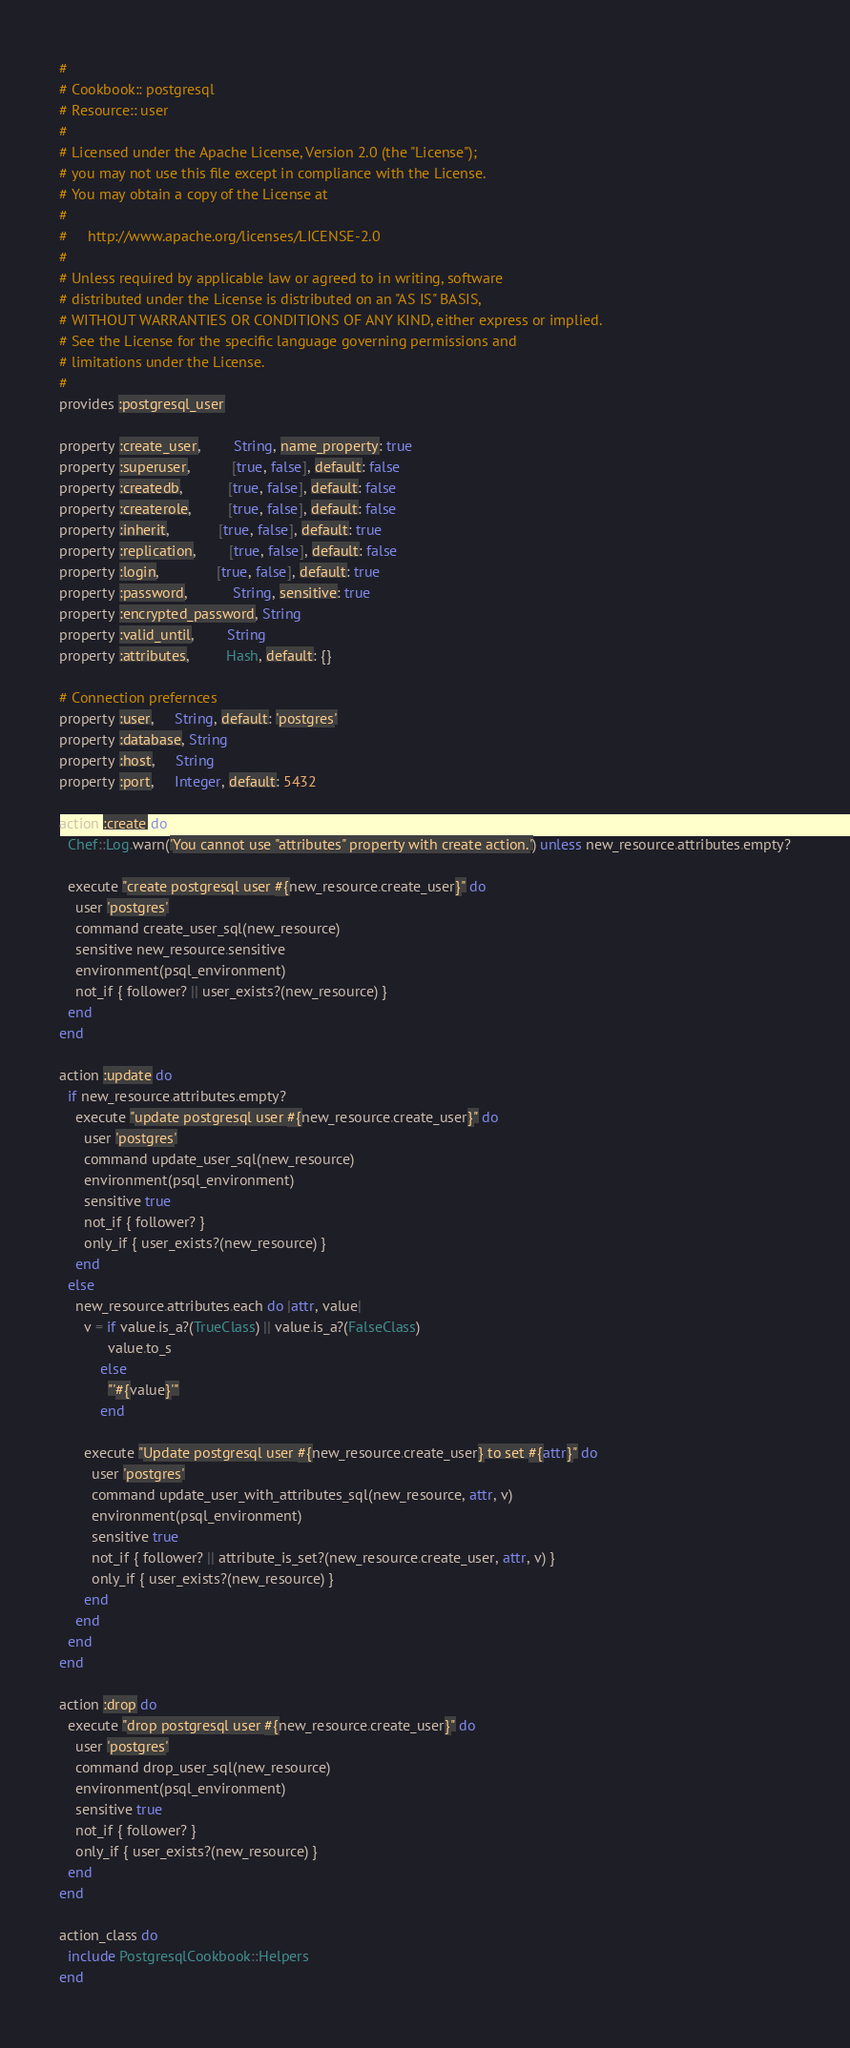Convert code to text. <code><loc_0><loc_0><loc_500><loc_500><_Ruby_>#
# Cookbook:: postgresql
# Resource:: user
#
# Licensed under the Apache License, Version 2.0 (the "License");
# you may not use this file except in compliance with the License.
# You may obtain a copy of the License at
#
#     http://www.apache.org/licenses/LICENSE-2.0
#
# Unless required by applicable law or agreed to in writing, software
# distributed under the License is distributed on an "AS IS" BASIS,
# WITHOUT WARRANTIES OR CONDITIONS OF ANY KIND, either express or implied.
# See the License for the specific language governing permissions and
# limitations under the License.
#
provides :postgresql_user

property :create_user,        String, name_property: true
property :superuser,          [true, false], default: false
property :createdb,           [true, false], default: false
property :createrole,         [true, false], default: false
property :inherit,            [true, false], default: true
property :replication,        [true, false], default: false
property :login,              [true, false], default: true
property :password,           String, sensitive: true
property :encrypted_password, String
property :valid_until,        String
property :attributes,         Hash, default: {}

# Connection prefernces
property :user,     String, default: 'postgres'
property :database, String
property :host,     String
property :port,     Integer, default: 5432

action :create do
  Chef::Log.warn('You cannot use "attributes" property with create action.') unless new_resource.attributes.empty?

  execute "create postgresql user #{new_resource.create_user}" do
    user 'postgres'
    command create_user_sql(new_resource)
    sensitive new_resource.sensitive
    environment(psql_environment)
    not_if { follower? || user_exists?(new_resource) }
  end
end

action :update do
  if new_resource.attributes.empty?
    execute "update postgresql user #{new_resource.create_user}" do
      user 'postgres'
      command update_user_sql(new_resource)
      environment(psql_environment)
      sensitive true
      not_if { follower? }
      only_if { user_exists?(new_resource) }
    end
  else
    new_resource.attributes.each do |attr, value|
      v = if value.is_a?(TrueClass) || value.is_a?(FalseClass)
            value.to_s
          else
            "'#{value}'"
          end

      execute "Update postgresql user #{new_resource.create_user} to set #{attr}" do
        user 'postgres'
        command update_user_with_attributes_sql(new_resource, attr, v)
        environment(psql_environment)
        sensitive true
        not_if { follower? || attribute_is_set?(new_resource.create_user, attr, v) }
        only_if { user_exists?(new_resource) }
      end
    end
  end
end

action :drop do
  execute "drop postgresql user #{new_resource.create_user}" do
    user 'postgres'
    command drop_user_sql(new_resource)
    environment(psql_environment)
    sensitive true
    not_if { follower? }
    only_if { user_exists?(new_resource) }
  end
end

action_class do
  include PostgresqlCookbook::Helpers
end
</code> 